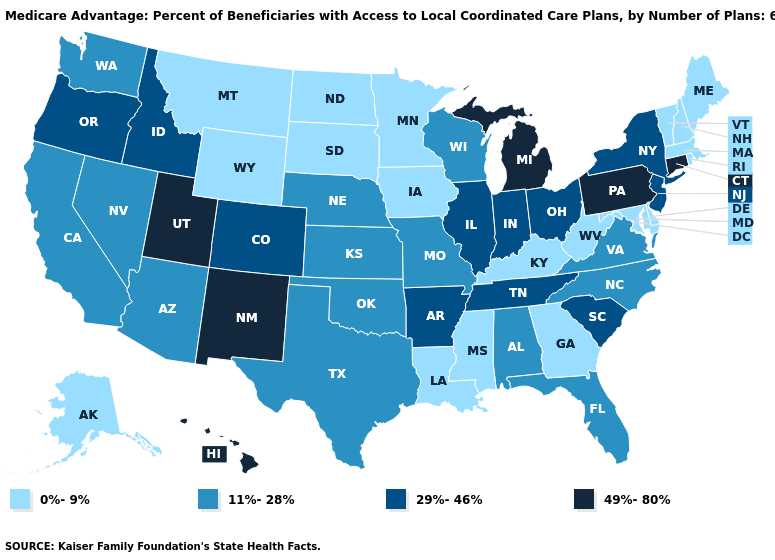Does Wyoming have the lowest value in the West?
Quick response, please. Yes. Name the states that have a value in the range 49%-80%?
Write a very short answer. Connecticut, Hawaii, Michigan, New Mexico, Pennsylvania, Utah. Name the states that have a value in the range 49%-80%?
Write a very short answer. Connecticut, Hawaii, Michigan, New Mexico, Pennsylvania, Utah. Does South Dakota have the lowest value in the USA?
Write a very short answer. Yes. Name the states that have a value in the range 0%-9%?
Be succinct. Alaska, Delaware, Georgia, Iowa, Kentucky, Louisiana, Massachusetts, Maryland, Maine, Minnesota, Mississippi, Montana, North Dakota, New Hampshire, Rhode Island, South Dakota, Vermont, West Virginia, Wyoming. Name the states that have a value in the range 29%-46%?
Write a very short answer. Arkansas, Colorado, Idaho, Illinois, Indiana, New Jersey, New York, Ohio, Oregon, South Carolina, Tennessee. Does South Carolina have the highest value in the South?
Be succinct. Yes. How many symbols are there in the legend?
Answer briefly. 4. What is the highest value in the USA?
Concise answer only. 49%-80%. Does Vermont have the lowest value in the Northeast?
Give a very brief answer. Yes. Which states hav the highest value in the Northeast?
Give a very brief answer. Connecticut, Pennsylvania. Name the states that have a value in the range 0%-9%?
Be succinct. Alaska, Delaware, Georgia, Iowa, Kentucky, Louisiana, Massachusetts, Maryland, Maine, Minnesota, Mississippi, Montana, North Dakota, New Hampshire, Rhode Island, South Dakota, Vermont, West Virginia, Wyoming. What is the lowest value in states that border South Carolina?
Concise answer only. 0%-9%. What is the lowest value in the USA?
Answer briefly. 0%-9%. Name the states that have a value in the range 11%-28%?
Write a very short answer. Alabama, Arizona, California, Florida, Kansas, Missouri, North Carolina, Nebraska, Nevada, Oklahoma, Texas, Virginia, Washington, Wisconsin. 